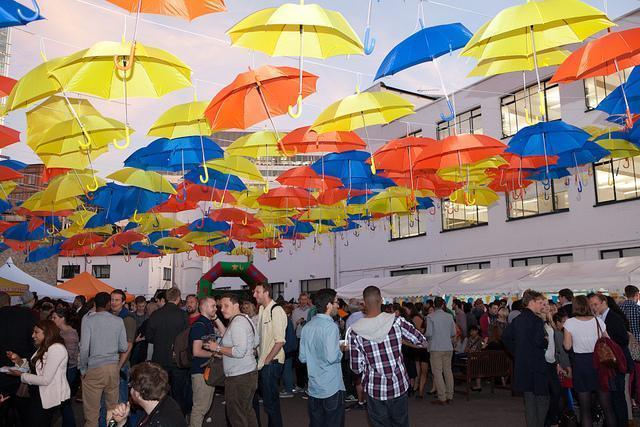How many black umbrellas?
Give a very brief answer. 0. How many people are visible?
Give a very brief answer. 11. How many umbrellas are visible?
Give a very brief answer. 11. 